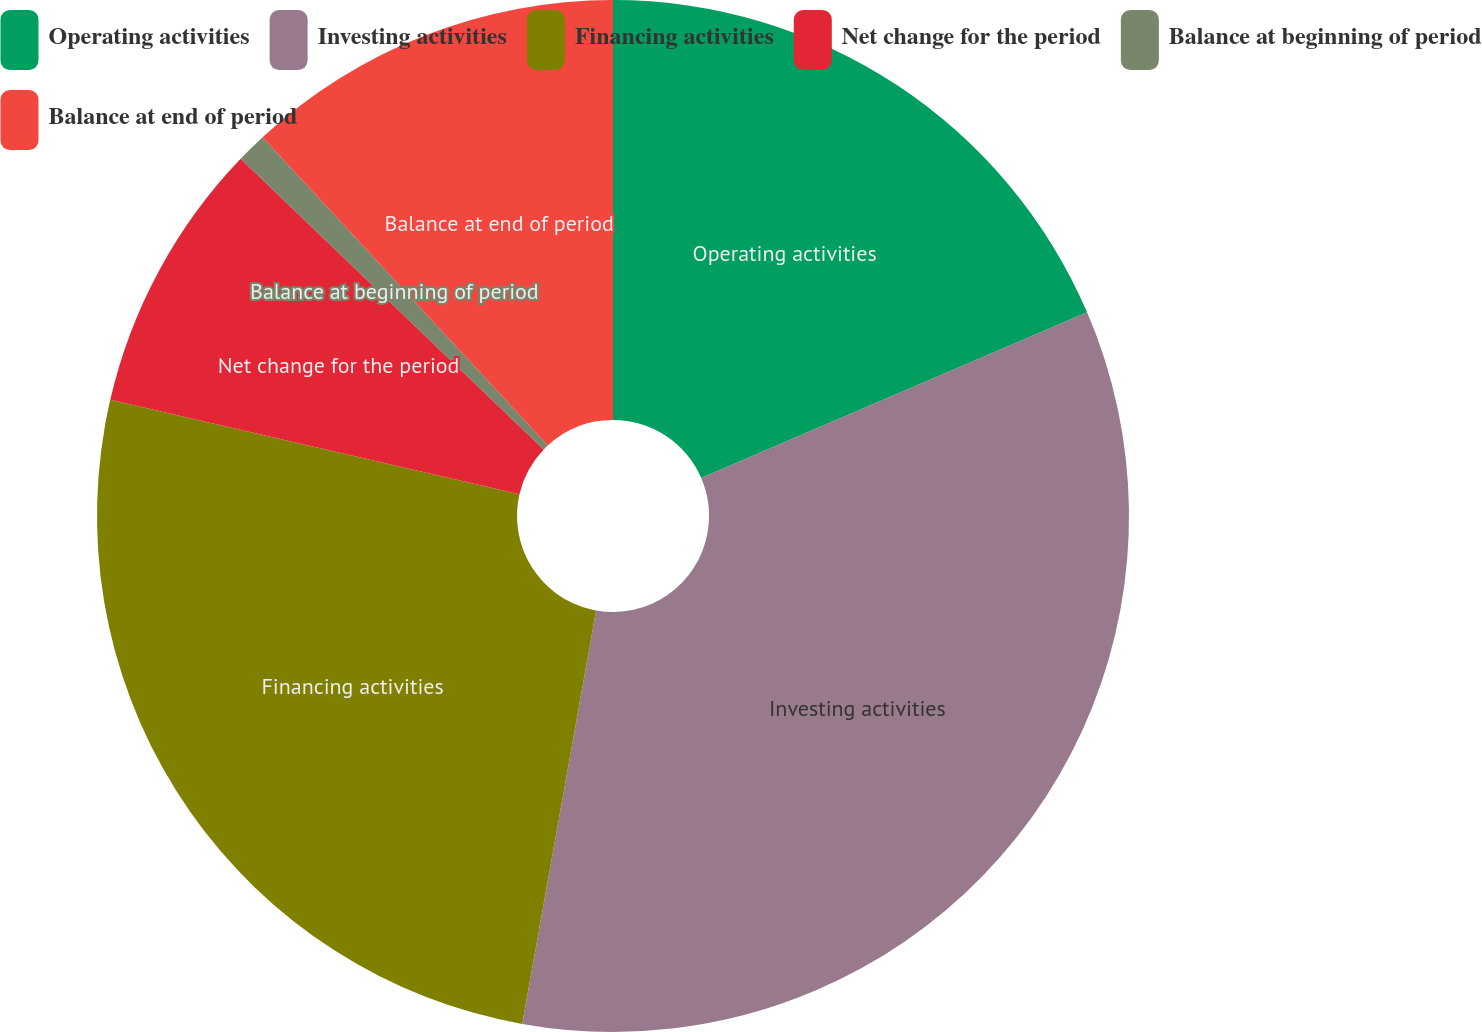Convert chart to OTSL. <chart><loc_0><loc_0><loc_500><loc_500><pie_chart><fcel>Operating activities<fcel>Investing activities<fcel>Financing activities<fcel>Net change for the period<fcel>Balance at beginning of period<fcel>Balance at end of period<nl><fcel>18.54%<fcel>34.27%<fcel>25.8%<fcel>8.55%<fcel>0.95%<fcel>11.88%<nl></chart> 